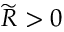Convert formula to latex. <formula><loc_0><loc_0><loc_500><loc_500>\widetilde { R } > 0</formula> 